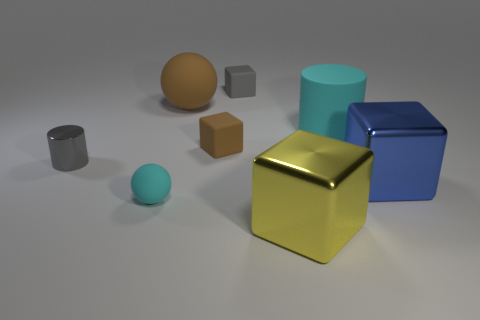Subtract all brown rubber blocks. How many blocks are left? 3 Subtract all gray cylinders. How many cylinders are left? 1 Subtract 1 cylinders. How many cylinders are left? 1 Add 7 tiny cylinders. How many tiny cylinders are left? 8 Add 5 tiny cyan balls. How many tiny cyan balls exist? 6 Add 1 brown rubber balls. How many objects exist? 9 Subtract 0 yellow balls. How many objects are left? 8 Subtract all balls. How many objects are left? 6 Subtract all brown balls. Subtract all brown cylinders. How many balls are left? 1 Subtract all purple cylinders. How many yellow cubes are left? 1 